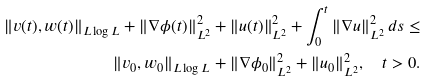Convert formula to latex. <formula><loc_0><loc_0><loc_500><loc_500>\| v ( t ) , w ( t ) \| _ { L \log L } + \| \nabla \phi ( t ) \| _ { L ^ { 2 } } ^ { 2 } + \| u ( t ) \| _ { L ^ { 2 } } ^ { 2 } + \int _ { 0 } ^ { t } \| \nabla u \| _ { L ^ { 2 } } ^ { 2 } \, d s \leq \\ \| v _ { 0 } , w _ { 0 } \| _ { L \log L } + \| \nabla \phi _ { 0 } \| _ { L ^ { 2 } } ^ { 2 } + \| u _ { 0 } \| _ { L ^ { 2 } } ^ { 2 } , \quad t > 0 .</formula> 